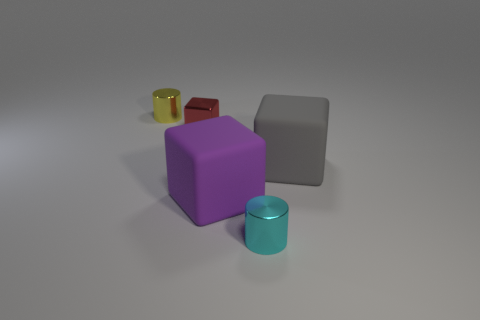There is a large gray rubber thing; is it the same shape as the big rubber object to the left of the cyan cylinder?
Keep it short and to the point. Yes. What number of blocks are large rubber objects or purple things?
Offer a very short reply. 2. Is there another tiny thing of the same shape as the purple rubber object?
Your answer should be compact. Yes. Is the number of large gray rubber things that are to the right of the gray rubber thing less than the number of yellow shiny cylinders?
Make the answer very short. Yes. How many tiny metal things are there?
Offer a terse response. 3. What number of blue spheres are made of the same material as the gray block?
Provide a short and direct response. 0. How many objects are cyan objects that are left of the big gray thing or brown matte objects?
Give a very brief answer. 1. Are there fewer cylinders that are behind the yellow shiny object than large gray rubber cubes in front of the purple matte object?
Make the answer very short. No. Are there any large matte things behind the big purple rubber cube?
Your answer should be compact. Yes. How many objects are either small metallic cylinders that are behind the purple rubber block or shiny cylinders that are to the left of the cyan metal cylinder?
Provide a succinct answer. 1. 